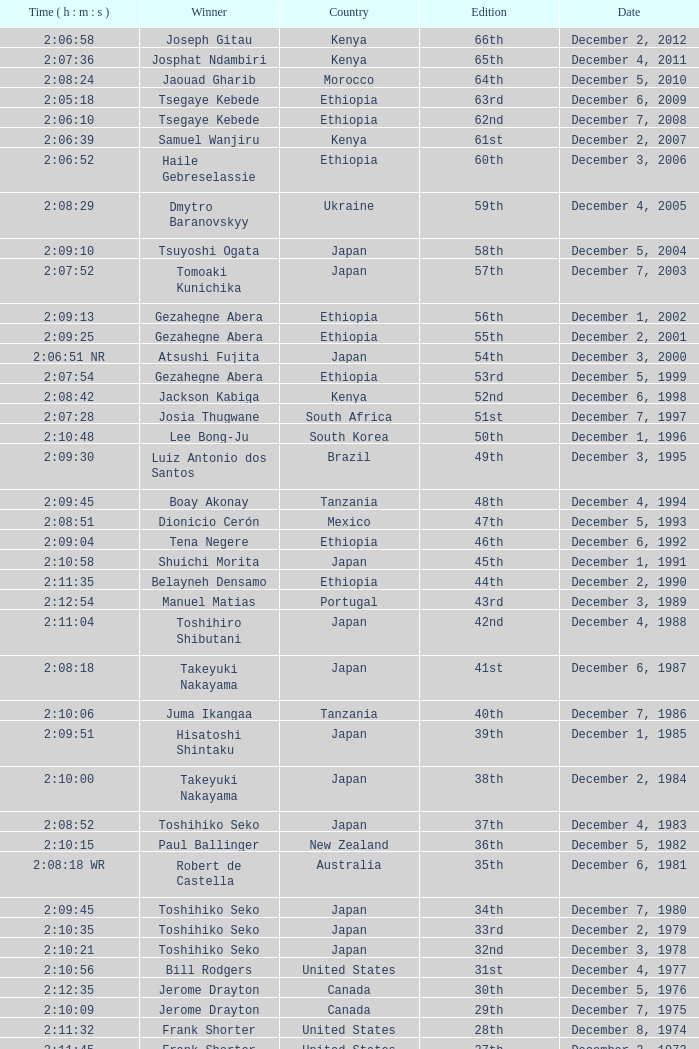What was the nationality of the winner for the 20th Edition? New Zealand. Could you parse the entire table? {'header': ['Time ( h : m : s )', 'Winner', 'Country', 'Edition', 'Date'], 'rows': [['2:06:58', 'Joseph Gitau', 'Kenya', '66th', 'December 2, 2012'], ['2:07:36', 'Josphat Ndambiri', 'Kenya', '65th', 'December 4, 2011'], ['2:08:24', 'Jaouad Gharib', 'Morocco', '64th', 'December 5, 2010'], ['2:05:18', 'Tsegaye Kebede', 'Ethiopia', '63rd', 'December 6, 2009'], ['2:06:10', 'Tsegaye Kebede', 'Ethiopia', '62nd', 'December 7, 2008'], ['2:06:39', 'Samuel Wanjiru', 'Kenya', '61st', 'December 2, 2007'], ['2:06:52', 'Haile Gebreselassie', 'Ethiopia', '60th', 'December 3, 2006'], ['2:08:29', 'Dmytro Baranovskyy', 'Ukraine', '59th', 'December 4, 2005'], ['2:09:10', 'Tsuyoshi Ogata', 'Japan', '58th', 'December 5, 2004'], ['2:07:52', 'Tomoaki Kunichika', 'Japan', '57th', 'December 7, 2003'], ['2:09:13', 'Gezahegne Abera', 'Ethiopia', '56th', 'December 1, 2002'], ['2:09:25', 'Gezahegne Abera', 'Ethiopia', '55th', 'December 2, 2001'], ['2:06:51 NR', 'Atsushi Fujita', 'Japan', '54th', 'December 3, 2000'], ['2:07:54', 'Gezahegne Abera', 'Ethiopia', '53rd', 'December 5, 1999'], ['2:08:42', 'Jackson Kabiga', 'Kenya', '52nd', 'December 6, 1998'], ['2:07:28', 'Josia Thugwane', 'South Africa', '51st', 'December 7, 1997'], ['2:10:48', 'Lee Bong-Ju', 'South Korea', '50th', 'December 1, 1996'], ['2:09:30', 'Luiz Antonio dos Santos', 'Brazil', '49th', 'December 3, 1995'], ['2:09:45', 'Boay Akonay', 'Tanzania', '48th', 'December 4, 1994'], ['2:08:51', 'Dionicio Cerón', 'Mexico', '47th', 'December 5, 1993'], ['2:09:04', 'Tena Negere', 'Ethiopia', '46th', 'December 6, 1992'], ['2:10:58', 'Shuichi Morita', 'Japan', '45th', 'December 1, 1991'], ['2:11:35', 'Belayneh Densamo', 'Ethiopia', '44th', 'December 2, 1990'], ['2:12:54', 'Manuel Matias', 'Portugal', '43rd', 'December 3, 1989'], ['2:11:04', 'Toshihiro Shibutani', 'Japan', '42nd', 'December 4, 1988'], ['2:08:18', 'Takeyuki Nakayama', 'Japan', '41st', 'December 6, 1987'], ['2:10:06', 'Juma Ikangaa', 'Tanzania', '40th', 'December 7, 1986'], ['2:09:51', 'Hisatoshi Shintaku', 'Japan', '39th', 'December 1, 1985'], ['2:10:00', 'Takeyuki Nakayama', 'Japan', '38th', 'December 2, 1984'], ['2:08:52', 'Toshihiko Seko', 'Japan', '37th', 'December 4, 1983'], ['2:10:15', 'Paul Ballinger', 'New Zealand', '36th', 'December 5, 1982'], ['2:08:18 WR', 'Robert de Castella', 'Australia', '35th', 'December 6, 1981'], ['2:09:45', 'Toshihiko Seko', 'Japan', '34th', 'December 7, 1980'], ['2:10:35', 'Toshihiko Seko', 'Japan', '33rd', 'December 2, 1979'], ['2:10:21', 'Toshihiko Seko', 'Japan', '32nd', 'December 3, 1978'], ['2:10:56', 'Bill Rodgers', 'United States', '31st', 'December 4, 1977'], ['2:12:35', 'Jerome Drayton', 'Canada', '30th', 'December 5, 1976'], ['2:10:09', 'Jerome Drayton', 'Canada', '29th', 'December 7, 1975'], ['2:11:32', 'Frank Shorter', 'United States', '28th', 'December 8, 1974'], ['2:11:45', 'Frank Shorter', 'United States', '27th', 'December 2, 1973'], ['2:10:30', 'Frank Shorter', 'United States', '26th', 'December 3, 1972'], ['2:12:51', 'Frank Shorter', 'United States', '25th', 'December 5, 1971'], ['2:10:38', 'Akio Usami', 'Japan', '24th', 'December 6, 1970'], ['2:11:13', 'Jerome Drayton', 'Canada', '23rd', 'December 7, 1969'], ['2:10:48', 'Bill Adcocks', 'England', '22nd', 'December 8, 1968'], ['2:09:37 WR', 'Derek Clayton', 'Australia', '21st', 'December 3, 1967'], ['2:14:05', 'Mike Ryan', 'New Zealand', '20th', 'November 27, 1966'], ['2:18:36', 'Hidekuni Hiroshima', 'Japan', '19th', 'October 10, 1965'], ['2:14:49', 'Toru Terasawa', 'Japan', '18th', 'December 6, 1964'], ['2:18:01', 'Jeff Julian', 'New Zealand', '17th', 'October 15, 1963'], ['2:16:19', 'Toru Terasawa', 'Japan', '16th', 'December 2, 1962'], ['2:22:05', 'Pavel Kantorek', 'Czech Republic', '15th', 'December 3, 1961'], ['2:19:04', 'Barry Magee', 'New Zealand', '14th', 'December 4, 1960'], ['2:29:34', 'Kurao Hiroshima', 'Japan', '13th', 'November 8, 1959'], ['2:24:01', 'Nobuyoshi Sadanaga', 'Japan', '12th', 'December 7, 1958'], ['2:21:40', 'Kurao Hiroshima', 'Japan', '11th', 'December 1, 1957'], ['2:25:15', 'Keizo Yamada', 'Japan', '10th', 'December 9, 1956'], ['2:23:16', 'Veikko Karvonen', 'Finland', '9th', 'December 11, 1955'], ['2:24:55', 'Reinaldo Gorno', 'Argentina', '8th', 'December 5, 1954'], ['2:27:26', 'Hideo Hamamura', 'Japan', '7th', 'December 6, 1953'], ['2:27:59', 'Katsuo Nishida', 'Japan', '6th', 'December 7, 1952'], ['2:30:13', 'Hiromi Haigo', 'Japan', '5th', 'December 9, 1951'], ['2:30:47', 'Shunji Koyanagi', 'Japan', '4th', 'December 10, 1950'], ['2:40:26', 'Shinzo Koga', 'Japan', '3rd', 'December 4, 1949'], ['2:37:25', 'Saburo Yamada', 'Japan', '2nd', 'December 5, 1948'], ['2:45:45', 'Toshikazu Wada', 'Japan', '1st', 'December 7, 1947']]} 